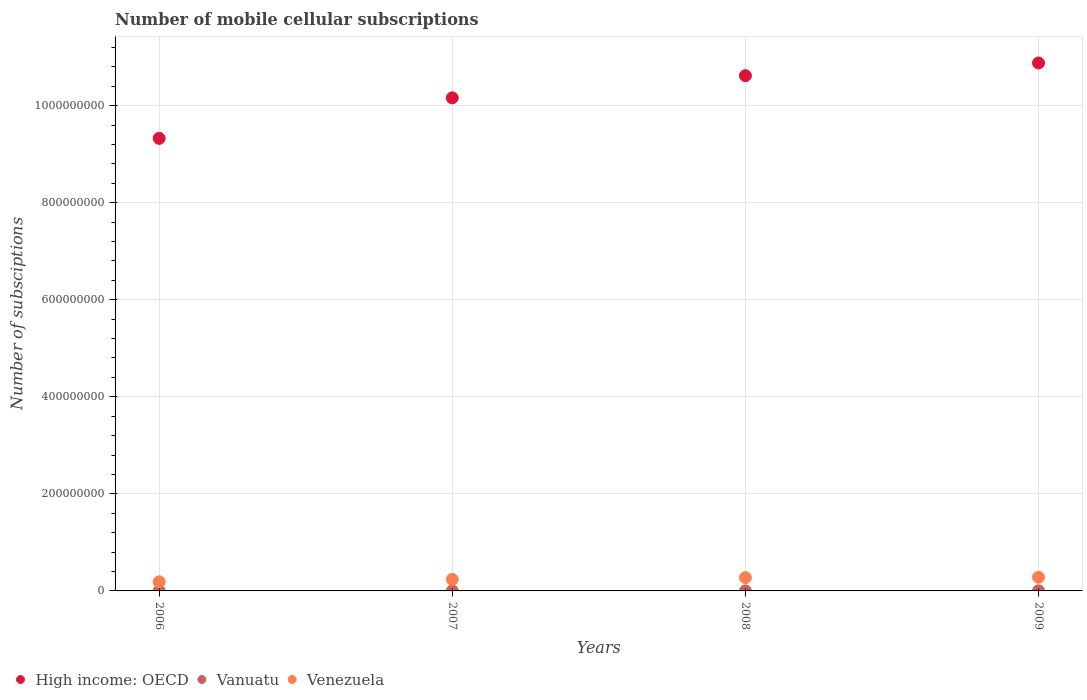How many different coloured dotlines are there?
Offer a terse response. 3. Is the number of dotlines equal to the number of legend labels?
Offer a terse response. Yes. What is the number of mobile cellular subscriptions in Vanuatu in 2007?
Provide a succinct answer. 2.60e+04. Across all years, what is the maximum number of mobile cellular subscriptions in High income: OECD?
Make the answer very short. 1.09e+09. Across all years, what is the minimum number of mobile cellular subscriptions in Venezuela?
Your response must be concise. 1.88e+07. In which year was the number of mobile cellular subscriptions in Venezuela maximum?
Your answer should be very brief. 2009. What is the total number of mobile cellular subscriptions in High income: OECD in the graph?
Provide a short and direct response. 4.10e+09. What is the difference between the number of mobile cellular subscriptions in Venezuela in 2007 and that in 2008?
Offer a terse response. -3.59e+06. What is the difference between the number of mobile cellular subscriptions in Venezuela in 2006 and the number of mobile cellular subscriptions in Vanuatu in 2007?
Give a very brief answer. 1.88e+07. What is the average number of mobile cellular subscriptions in High income: OECD per year?
Offer a terse response. 1.02e+09. In the year 2008, what is the difference between the number of mobile cellular subscriptions in Vanuatu and number of mobile cellular subscriptions in High income: OECD?
Provide a short and direct response. -1.06e+09. In how many years, is the number of mobile cellular subscriptions in Vanuatu greater than 320000000?
Provide a succinct answer. 0. What is the ratio of the number of mobile cellular subscriptions in High income: OECD in 2007 to that in 2009?
Your response must be concise. 0.93. Is the number of mobile cellular subscriptions in High income: OECD in 2008 less than that in 2009?
Provide a succinct answer. Yes. What is the difference between the highest and the second highest number of mobile cellular subscriptions in Vanuatu?
Provide a short and direct response. 9.57e+04. What is the difference between the highest and the lowest number of mobile cellular subscriptions in High income: OECD?
Your response must be concise. 1.55e+08. In how many years, is the number of mobile cellular subscriptions in Vanuatu greater than the average number of mobile cellular subscriptions in Vanuatu taken over all years?
Provide a short and direct response. 1. Is the sum of the number of mobile cellular subscriptions in Vanuatu in 2008 and 2009 greater than the maximum number of mobile cellular subscriptions in High income: OECD across all years?
Provide a short and direct response. No. Is it the case that in every year, the sum of the number of mobile cellular subscriptions in Venezuela and number of mobile cellular subscriptions in Vanuatu  is greater than the number of mobile cellular subscriptions in High income: OECD?
Your answer should be compact. No. Is the number of mobile cellular subscriptions in Venezuela strictly less than the number of mobile cellular subscriptions in High income: OECD over the years?
Offer a very short reply. Yes. How many dotlines are there?
Provide a short and direct response. 3. How many years are there in the graph?
Your answer should be compact. 4. What is the difference between two consecutive major ticks on the Y-axis?
Ensure brevity in your answer.  2.00e+08. Does the graph contain grids?
Keep it short and to the point. Yes. Where does the legend appear in the graph?
Make the answer very short. Bottom left. How are the legend labels stacked?
Offer a very short reply. Horizontal. What is the title of the graph?
Provide a short and direct response. Number of mobile cellular subscriptions. What is the label or title of the Y-axis?
Offer a terse response. Number of subsciptions. What is the Number of subsciptions in High income: OECD in 2006?
Offer a terse response. 9.33e+08. What is the Number of subsciptions in Vanuatu in 2006?
Ensure brevity in your answer.  1.50e+04. What is the Number of subsciptions in Venezuela in 2006?
Provide a succinct answer. 1.88e+07. What is the Number of subsciptions of High income: OECD in 2007?
Your answer should be compact. 1.02e+09. What is the Number of subsciptions in Vanuatu in 2007?
Make the answer very short. 2.60e+04. What is the Number of subsciptions in Venezuela in 2007?
Make the answer very short. 2.38e+07. What is the Number of subsciptions in High income: OECD in 2008?
Offer a very short reply. 1.06e+09. What is the Number of subsciptions of Vanuatu in 2008?
Your answer should be very brief. 3.60e+04. What is the Number of subsciptions in Venezuela in 2008?
Offer a terse response. 2.74e+07. What is the Number of subsciptions in High income: OECD in 2009?
Ensure brevity in your answer.  1.09e+09. What is the Number of subsciptions of Vanuatu in 2009?
Offer a very short reply. 1.32e+05. What is the Number of subsciptions in Venezuela in 2009?
Provide a short and direct response. 2.81e+07. Across all years, what is the maximum Number of subsciptions of High income: OECD?
Provide a succinct answer. 1.09e+09. Across all years, what is the maximum Number of subsciptions in Vanuatu?
Your answer should be compact. 1.32e+05. Across all years, what is the maximum Number of subsciptions in Venezuela?
Keep it short and to the point. 2.81e+07. Across all years, what is the minimum Number of subsciptions in High income: OECD?
Make the answer very short. 9.33e+08. Across all years, what is the minimum Number of subsciptions in Vanuatu?
Your response must be concise. 1.50e+04. Across all years, what is the minimum Number of subsciptions of Venezuela?
Offer a terse response. 1.88e+07. What is the total Number of subsciptions of High income: OECD in the graph?
Provide a succinct answer. 4.10e+09. What is the total Number of subsciptions of Vanuatu in the graph?
Make the answer very short. 2.09e+05. What is the total Number of subsciptions of Venezuela in the graph?
Offer a terse response. 9.81e+07. What is the difference between the Number of subsciptions in High income: OECD in 2006 and that in 2007?
Ensure brevity in your answer.  -8.35e+07. What is the difference between the Number of subsciptions of Vanuatu in 2006 and that in 2007?
Offer a terse response. -1.10e+04. What is the difference between the Number of subsciptions of Venezuela in 2006 and that in 2007?
Your answer should be very brief. -5.03e+06. What is the difference between the Number of subsciptions in High income: OECD in 2006 and that in 2008?
Your answer should be very brief. -1.29e+08. What is the difference between the Number of subsciptions of Vanuatu in 2006 and that in 2008?
Provide a succinct answer. -2.10e+04. What is the difference between the Number of subsciptions of Venezuela in 2006 and that in 2008?
Make the answer very short. -8.62e+06. What is the difference between the Number of subsciptions of High income: OECD in 2006 and that in 2009?
Your answer should be compact. -1.55e+08. What is the difference between the Number of subsciptions of Vanuatu in 2006 and that in 2009?
Provide a succinct answer. -1.17e+05. What is the difference between the Number of subsciptions of Venezuela in 2006 and that in 2009?
Your answer should be compact. -9.33e+06. What is the difference between the Number of subsciptions in High income: OECD in 2007 and that in 2008?
Make the answer very short. -4.56e+07. What is the difference between the Number of subsciptions in Venezuela in 2007 and that in 2008?
Your answer should be compact. -3.59e+06. What is the difference between the Number of subsciptions in High income: OECD in 2007 and that in 2009?
Offer a terse response. -7.18e+07. What is the difference between the Number of subsciptions of Vanuatu in 2007 and that in 2009?
Make the answer very short. -1.06e+05. What is the difference between the Number of subsciptions of Venezuela in 2007 and that in 2009?
Provide a succinct answer. -4.30e+06. What is the difference between the Number of subsciptions of High income: OECD in 2008 and that in 2009?
Your answer should be very brief. -2.62e+07. What is the difference between the Number of subsciptions in Vanuatu in 2008 and that in 2009?
Your answer should be very brief. -9.57e+04. What is the difference between the Number of subsciptions of Venezuela in 2008 and that in 2009?
Provide a short and direct response. -7.09e+05. What is the difference between the Number of subsciptions in High income: OECD in 2006 and the Number of subsciptions in Vanuatu in 2007?
Offer a terse response. 9.33e+08. What is the difference between the Number of subsciptions of High income: OECD in 2006 and the Number of subsciptions of Venezuela in 2007?
Your answer should be very brief. 9.09e+08. What is the difference between the Number of subsciptions of Vanuatu in 2006 and the Number of subsciptions of Venezuela in 2007?
Your answer should be very brief. -2.38e+07. What is the difference between the Number of subsciptions of High income: OECD in 2006 and the Number of subsciptions of Vanuatu in 2008?
Offer a very short reply. 9.32e+08. What is the difference between the Number of subsciptions in High income: OECD in 2006 and the Number of subsciptions in Venezuela in 2008?
Your response must be concise. 9.05e+08. What is the difference between the Number of subsciptions of Vanuatu in 2006 and the Number of subsciptions of Venezuela in 2008?
Keep it short and to the point. -2.74e+07. What is the difference between the Number of subsciptions in High income: OECD in 2006 and the Number of subsciptions in Vanuatu in 2009?
Give a very brief answer. 9.32e+08. What is the difference between the Number of subsciptions in High income: OECD in 2006 and the Number of subsciptions in Venezuela in 2009?
Provide a short and direct response. 9.04e+08. What is the difference between the Number of subsciptions of Vanuatu in 2006 and the Number of subsciptions of Venezuela in 2009?
Provide a succinct answer. -2.81e+07. What is the difference between the Number of subsciptions of High income: OECD in 2007 and the Number of subsciptions of Vanuatu in 2008?
Provide a short and direct response. 1.02e+09. What is the difference between the Number of subsciptions in High income: OECD in 2007 and the Number of subsciptions in Venezuela in 2008?
Ensure brevity in your answer.  9.89e+08. What is the difference between the Number of subsciptions in Vanuatu in 2007 and the Number of subsciptions in Venezuela in 2008?
Keep it short and to the point. -2.74e+07. What is the difference between the Number of subsciptions in High income: OECD in 2007 and the Number of subsciptions in Vanuatu in 2009?
Provide a short and direct response. 1.02e+09. What is the difference between the Number of subsciptions in High income: OECD in 2007 and the Number of subsciptions in Venezuela in 2009?
Offer a terse response. 9.88e+08. What is the difference between the Number of subsciptions of Vanuatu in 2007 and the Number of subsciptions of Venezuela in 2009?
Make the answer very short. -2.81e+07. What is the difference between the Number of subsciptions in High income: OECD in 2008 and the Number of subsciptions in Vanuatu in 2009?
Your response must be concise. 1.06e+09. What is the difference between the Number of subsciptions in High income: OECD in 2008 and the Number of subsciptions in Venezuela in 2009?
Offer a terse response. 1.03e+09. What is the difference between the Number of subsciptions of Vanuatu in 2008 and the Number of subsciptions of Venezuela in 2009?
Keep it short and to the point. -2.81e+07. What is the average Number of subsciptions in High income: OECD per year?
Your response must be concise. 1.02e+09. What is the average Number of subsciptions of Vanuatu per year?
Your answer should be very brief. 5.22e+04. What is the average Number of subsciptions of Venezuela per year?
Offer a very short reply. 2.45e+07. In the year 2006, what is the difference between the Number of subsciptions of High income: OECD and Number of subsciptions of Vanuatu?
Offer a very short reply. 9.33e+08. In the year 2006, what is the difference between the Number of subsciptions in High income: OECD and Number of subsciptions in Venezuela?
Keep it short and to the point. 9.14e+08. In the year 2006, what is the difference between the Number of subsciptions of Vanuatu and Number of subsciptions of Venezuela?
Your answer should be very brief. -1.88e+07. In the year 2007, what is the difference between the Number of subsciptions of High income: OECD and Number of subsciptions of Vanuatu?
Give a very brief answer. 1.02e+09. In the year 2007, what is the difference between the Number of subsciptions in High income: OECD and Number of subsciptions in Venezuela?
Your answer should be very brief. 9.92e+08. In the year 2007, what is the difference between the Number of subsciptions in Vanuatu and Number of subsciptions in Venezuela?
Keep it short and to the point. -2.38e+07. In the year 2008, what is the difference between the Number of subsciptions in High income: OECD and Number of subsciptions in Vanuatu?
Provide a short and direct response. 1.06e+09. In the year 2008, what is the difference between the Number of subsciptions in High income: OECD and Number of subsciptions in Venezuela?
Your answer should be compact. 1.03e+09. In the year 2008, what is the difference between the Number of subsciptions in Vanuatu and Number of subsciptions in Venezuela?
Make the answer very short. -2.74e+07. In the year 2009, what is the difference between the Number of subsciptions in High income: OECD and Number of subsciptions in Vanuatu?
Your response must be concise. 1.09e+09. In the year 2009, what is the difference between the Number of subsciptions in High income: OECD and Number of subsciptions in Venezuela?
Provide a succinct answer. 1.06e+09. In the year 2009, what is the difference between the Number of subsciptions of Vanuatu and Number of subsciptions of Venezuela?
Make the answer very short. -2.80e+07. What is the ratio of the Number of subsciptions of High income: OECD in 2006 to that in 2007?
Give a very brief answer. 0.92. What is the ratio of the Number of subsciptions of Vanuatu in 2006 to that in 2007?
Provide a succinct answer. 0.58. What is the ratio of the Number of subsciptions in Venezuela in 2006 to that in 2007?
Your answer should be very brief. 0.79. What is the ratio of the Number of subsciptions in High income: OECD in 2006 to that in 2008?
Offer a terse response. 0.88. What is the ratio of the Number of subsciptions of Vanuatu in 2006 to that in 2008?
Make the answer very short. 0.42. What is the ratio of the Number of subsciptions in Venezuela in 2006 to that in 2008?
Your answer should be compact. 0.69. What is the ratio of the Number of subsciptions in High income: OECD in 2006 to that in 2009?
Your answer should be very brief. 0.86. What is the ratio of the Number of subsciptions of Vanuatu in 2006 to that in 2009?
Offer a very short reply. 0.11. What is the ratio of the Number of subsciptions in Venezuela in 2006 to that in 2009?
Your answer should be very brief. 0.67. What is the ratio of the Number of subsciptions of Vanuatu in 2007 to that in 2008?
Your response must be concise. 0.72. What is the ratio of the Number of subsciptions of Venezuela in 2007 to that in 2008?
Give a very brief answer. 0.87. What is the ratio of the Number of subsciptions in High income: OECD in 2007 to that in 2009?
Make the answer very short. 0.93. What is the ratio of the Number of subsciptions in Vanuatu in 2007 to that in 2009?
Provide a succinct answer. 0.2. What is the ratio of the Number of subsciptions in Venezuela in 2007 to that in 2009?
Offer a terse response. 0.85. What is the ratio of the Number of subsciptions of High income: OECD in 2008 to that in 2009?
Provide a short and direct response. 0.98. What is the ratio of the Number of subsciptions in Vanuatu in 2008 to that in 2009?
Ensure brevity in your answer.  0.27. What is the ratio of the Number of subsciptions in Venezuela in 2008 to that in 2009?
Provide a short and direct response. 0.97. What is the difference between the highest and the second highest Number of subsciptions in High income: OECD?
Your answer should be compact. 2.62e+07. What is the difference between the highest and the second highest Number of subsciptions of Vanuatu?
Provide a succinct answer. 9.57e+04. What is the difference between the highest and the second highest Number of subsciptions of Venezuela?
Your answer should be compact. 7.09e+05. What is the difference between the highest and the lowest Number of subsciptions in High income: OECD?
Provide a succinct answer. 1.55e+08. What is the difference between the highest and the lowest Number of subsciptions of Vanuatu?
Your response must be concise. 1.17e+05. What is the difference between the highest and the lowest Number of subsciptions of Venezuela?
Give a very brief answer. 9.33e+06. 